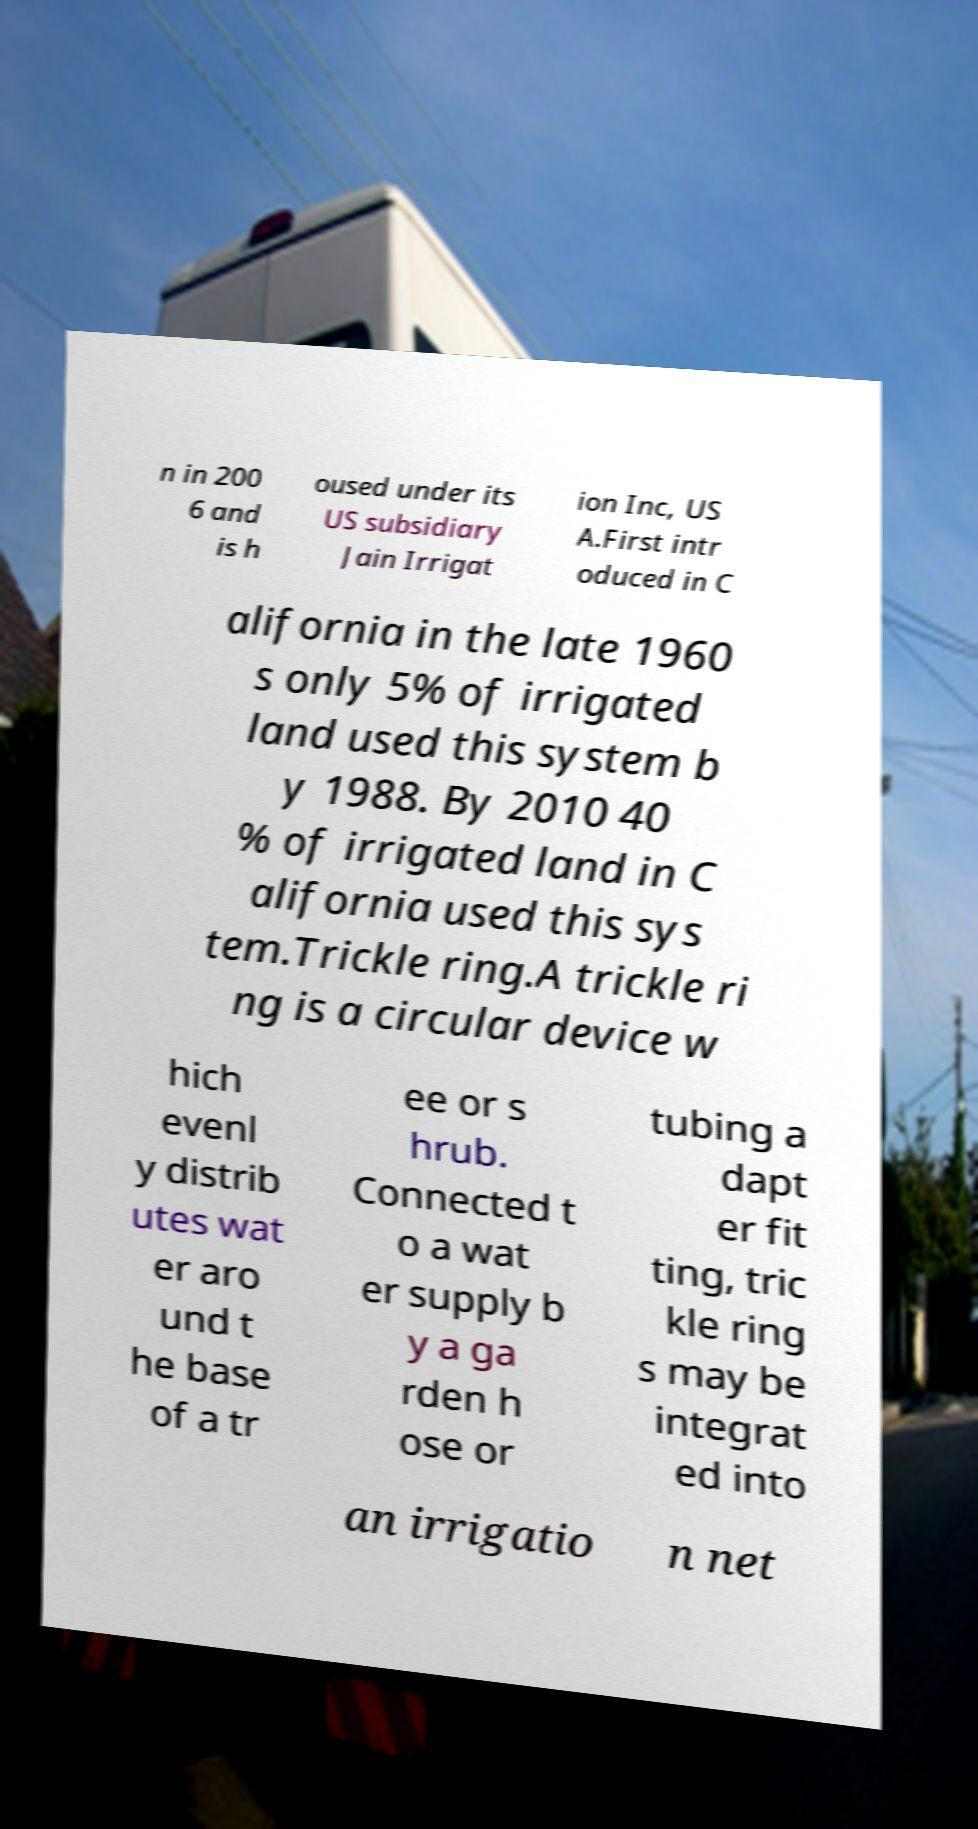I need the written content from this picture converted into text. Can you do that? n in 200 6 and is h oused under its US subsidiary Jain Irrigat ion Inc, US A.First intr oduced in C alifornia in the late 1960 s only 5% of irrigated land used this system b y 1988. By 2010 40 % of irrigated land in C alifornia used this sys tem.Trickle ring.A trickle ri ng is a circular device w hich evenl y distrib utes wat er aro und t he base of a tr ee or s hrub. Connected t o a wat er supply b y a ga rden h ose or tubing a dapt er fit ting, tric kle ring s may be integrat ed into an irrigatio n net 